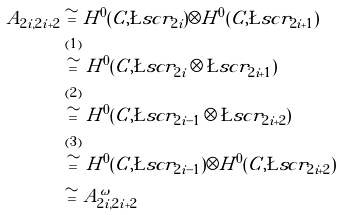<formula> <loc_0><loc_0><loc_500><loc_500>A _ { 2 i , 2 i + 2 } & \cong H ^ { 0 } ( C , \L s c r _ { 2 i } ) \otimes H ^ { 0 } ( C , \L s c r _ { 2 i + 1 } ) \\ & \overset { ( 1 ) } { \cong } H ^ { 0 } ( C , \L s c r _ { 2 i } \otimes \L s c r _ { 2 i + 1 } ) \\ & \overset { ( 2 ) } { \cong } H ^ { 0 } ( C , \L s c r _ { 2 i - 1 } \otimes \L s c r _ { 2 i + 2 } ) \\ & \overset { ( 3 ) } { \cong } H ^ { 0 } ( C , \L s c r _ { 2 i - 1 } ) \otimes H ^ { 0 } ( C , \L s c r _ { 2 i + 2 } ) \\ & \cong A ^ { \omega } _ { 2 i , 2 i + 2 }</formula> 